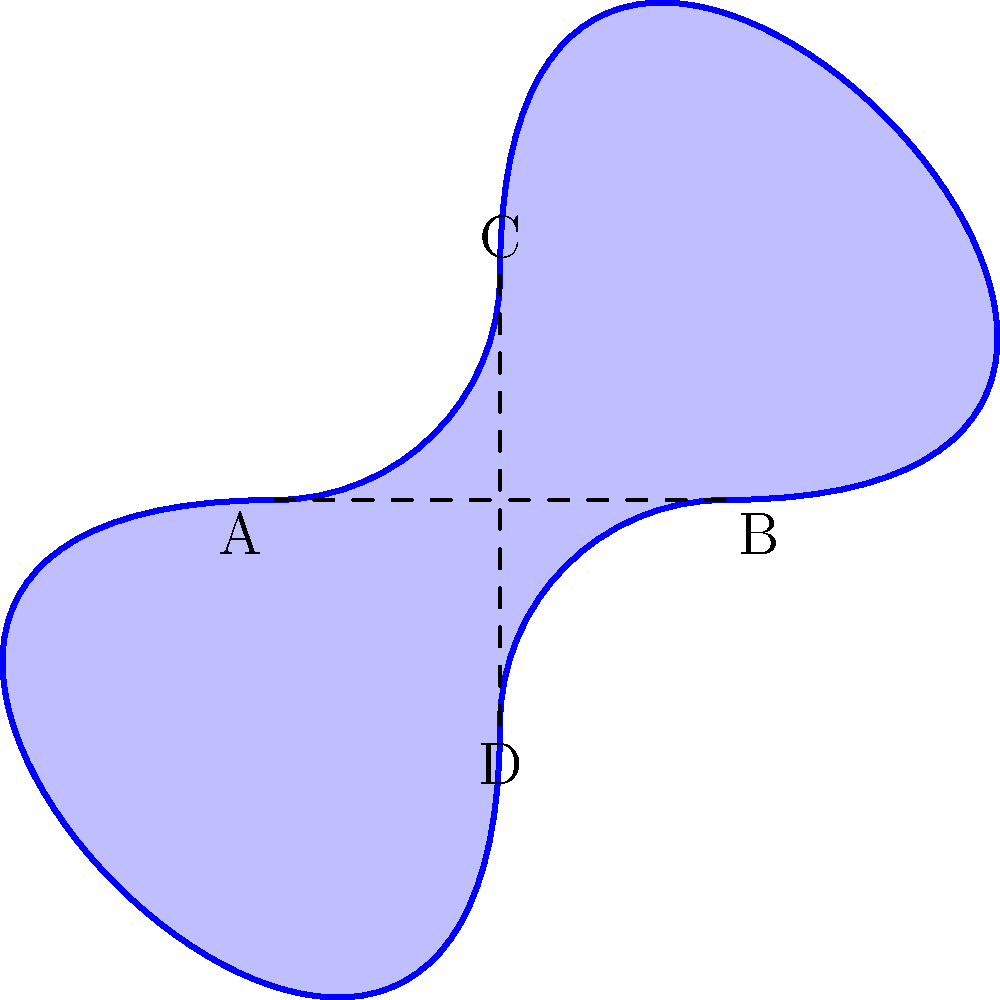A furniture designer wants to create a Möbius strip-inspired coffee table for a modern living room. The table's surface follows the path of a Möbius strip, as shown in the diagram. If the length of the strip (from A to B) is 6 feet, and the width (from C to D) is 3 feet, what is the surface area of the table in square feet? To find the surface area of the Möbius strip-inspired coffee table, we need to follow these steps:

1. Recall that a Möbius strip has only one side and one edge.

2. The formula for the surface area of a Möbius strip is:
   $A = \frac{1}{2} \times l \times w$
   Where $l$ is the length of the strip and $w$ is the width.

3. Given information:
   Length (l) = 6 feet
   Width (w) = 3 feet

4. Plug the values into the formula:
   $A = \frac{1}{2} \times 6 \times 3$

5. Calculate:
   $A = \frac{1}{2} \times 18 = 9$

Therefore, the surface area of the Möbius strip-inspired coffee table is 9 square feet.
Answer: 9 sq ft 